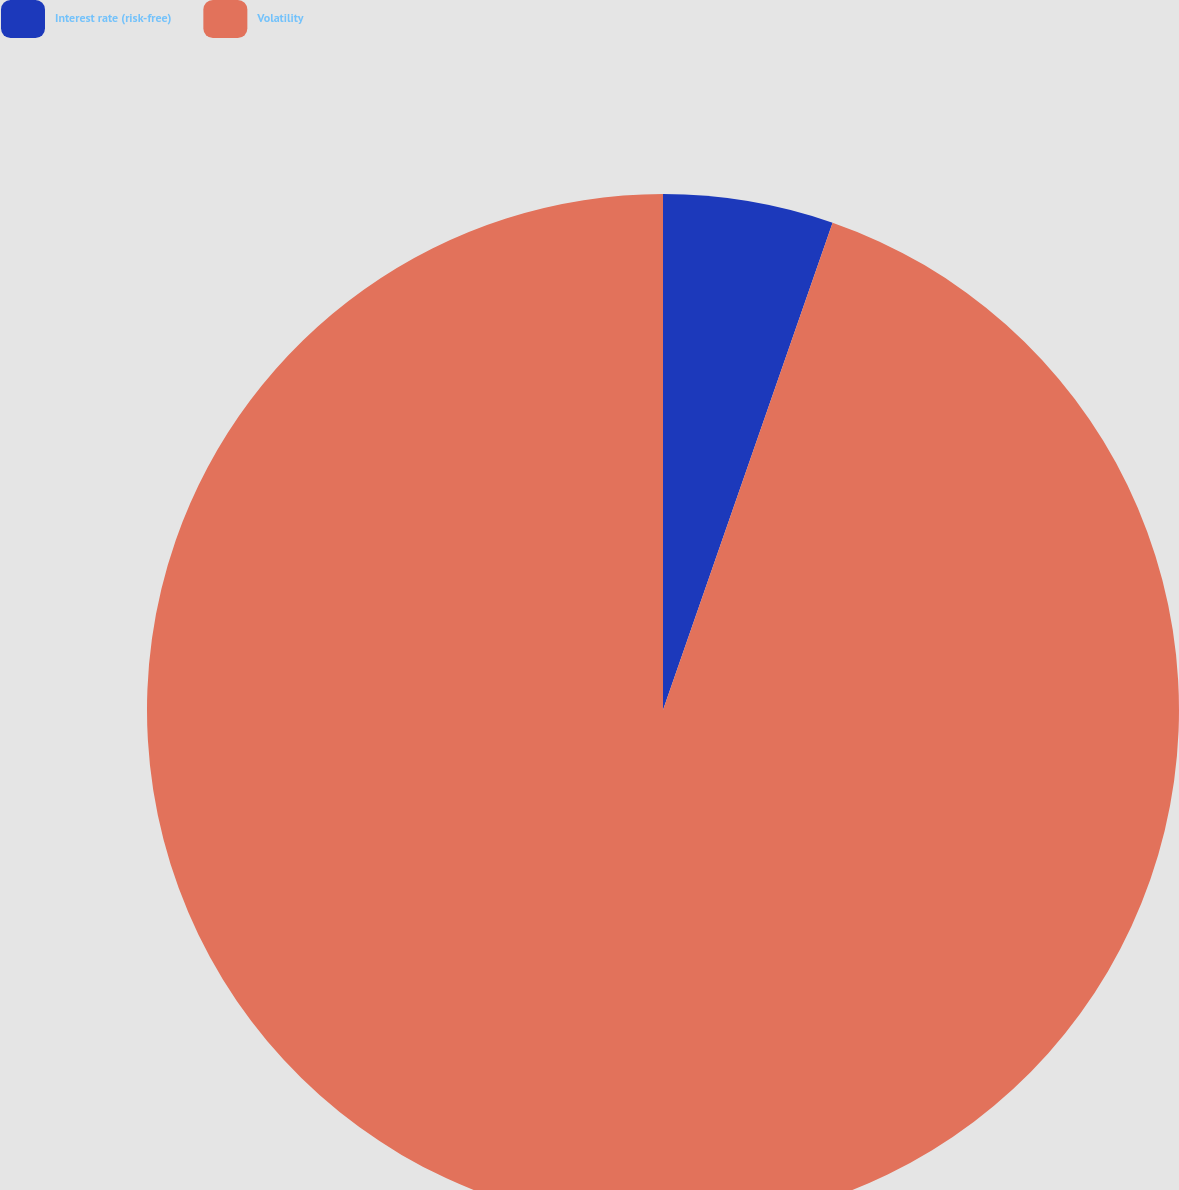Convert chart. <chart><loc_0><loc_0><loc_500><loc_500><pie_chart><fcel>Interest rate (risk-free)<fcel>Volatility<nl><fcel>5.33%<fcel>94.67%<nl></chart> 